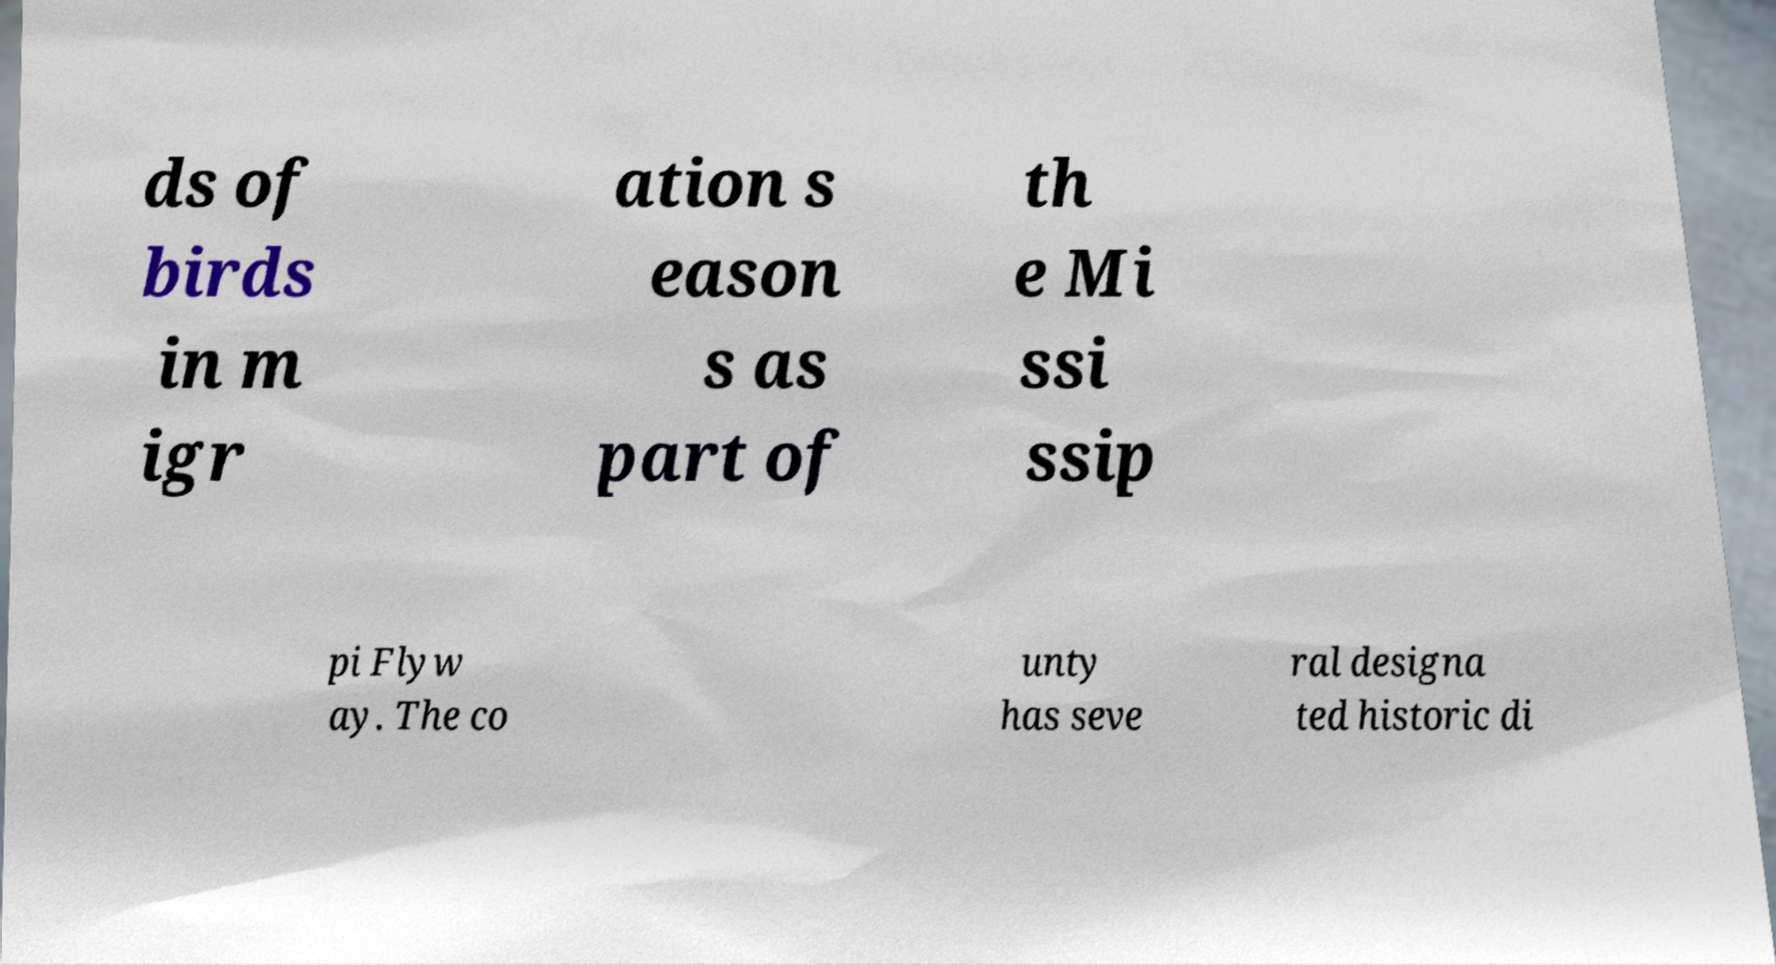Can you read and provide the text displayed in the image?This photo seems to have some interesting text. Can you extract and type it out for me? ds of birds in m igr ation s eason s as part of th e Mi ssi ssip pi Flyw ay. The co unty has seve ral designa ted historic di 